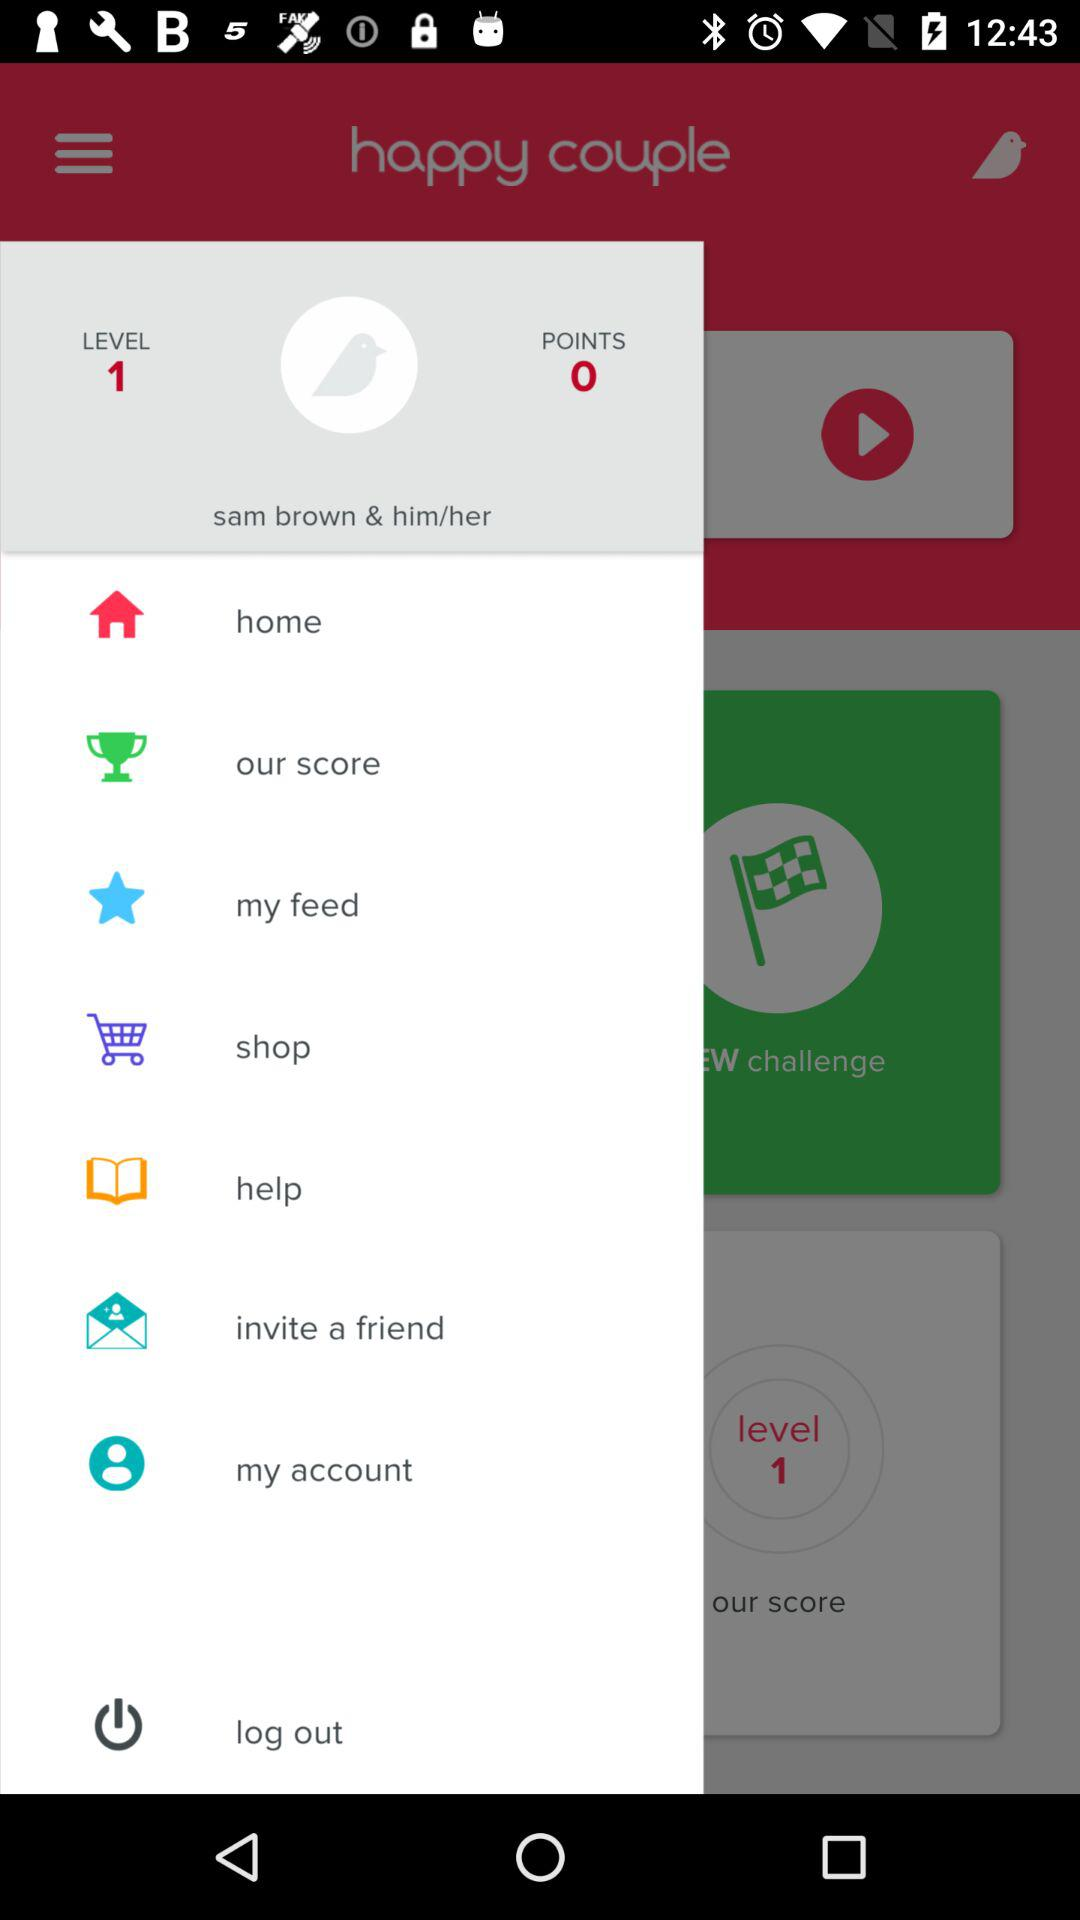What is the number of points? The number of points is 0. 